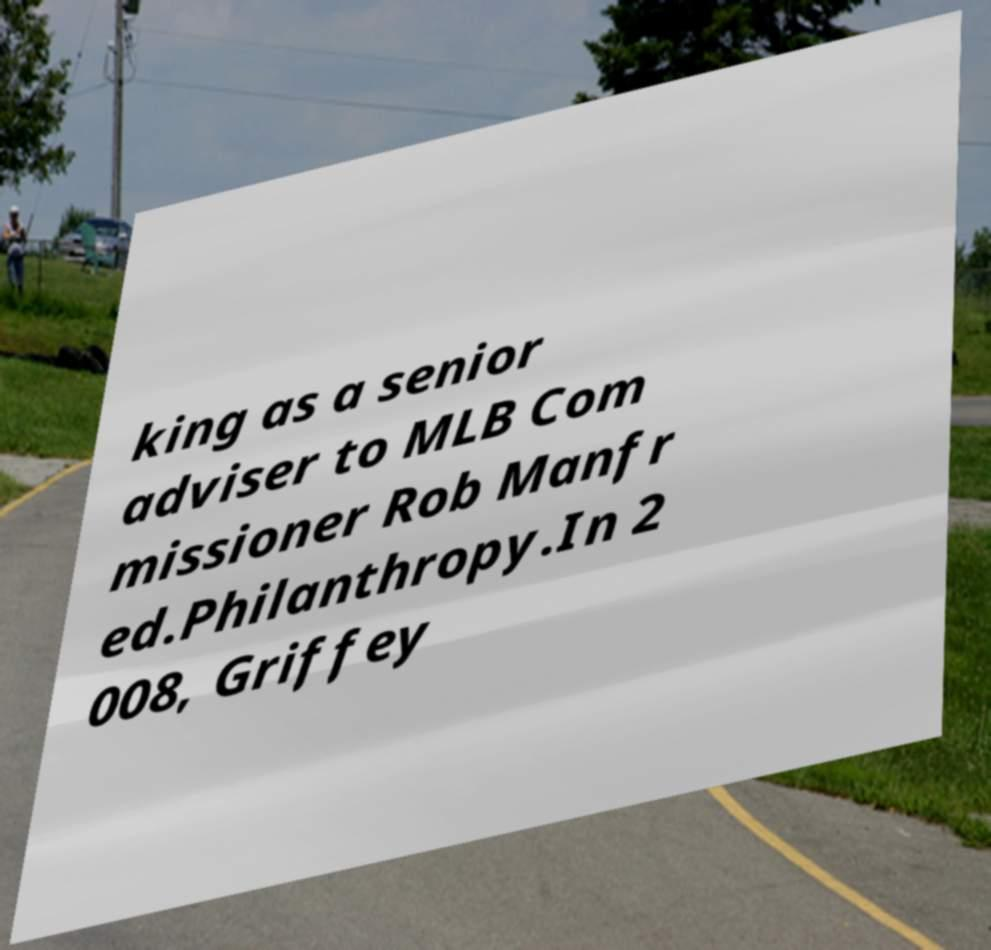There's text embedded in this image that I need extracted. Can you transcribe it verbatim? king as a senior adviser to MLB Com missioner Rob Manfr ed.Philanthropy.In 2 008, Griffey 